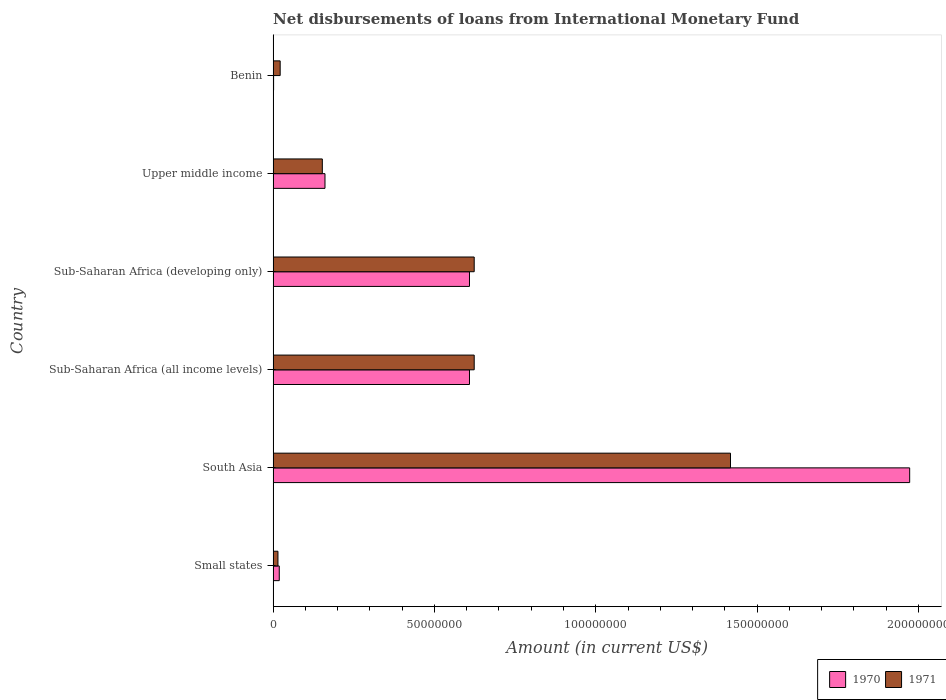How many different coloured bars are there?
Offer a terse response. 2. Are the number of bars per tick equal to the number of legend labels?
Your answer should be compact. Yes. Are the number of bars on each tick of the Y-axis equal?
Ensure brevity in your answer.  Yes. In how many cases, is the number of bars for a given country not equal to the number of legend labels?
Give a very brief answer. 0. What is the amount of loans disbursed in 1971 in Small states?
Offer a very short reply. 1.50e+06. Across all countries, what is the maximum amount of loans disbursed in 1970?
Provide a short and direct response. 1.97e+08. Across all countries, what is the minimum amount of loans disbursed in 1970?
Provide a succinct answer. 1.45e+05. In which country was the amount of loans disbursed in 1970 minimum?
Keep it short and to the point. Benin. What is the total amount of loans disbursed in 1970 in the graph?
Keep it short and to the point. 3.37e+08. What is the difference between the amount of loans disbursed in 1970 in Small states and that in Upper middle income?
Make the answer very short. -1.42e+07. What is the difference between the amount of loans disbursed in 1970 in Benin and the amount of loans disbursed in 1971 in Upper middle income?
Provide a succinct answer. -1.51e+07. What is the average amount of loans disbursed in 1971 per country?
Provide a succinct answer. 4.76e+07. What is the difference between the amount of loans disbursed in 1970 and amount of loans disbursed in 1971 in Small states?
Offer a very short reply. 4.08e+05. In how many countries, is the amount of loans disbursed in 1971 greater than 140000000 US$?
Give a very brief answer. 1. What is the ratio of the amount of loans disbursed in 1971 in Small states to that in Upper middle income?
Your response must be concise. 0.1. Is the amount of loans disbursed in 1971 in Small states less than that in South Asia?
Give a very brief answer. Yes. Is the difference between the amount of loans disbursed in 1970 in South Asia and Upper middle income greater than the difference between the amount of loans disbursed in 1971 in South Asia and Upper middle income?
Make the answer very short. Yes. What is the difference between the highest and the second highest amount of loans disbursed in 1970?
Offer a very short reply. 1.36e+08. What is the difference between the highest and the lowest amount of loans disbursed in 1970?
Your response must be concise. 1.97e+08. What does the 1st bar from the top in South Asia represents?
Provide a succinct answer. 1971. What does the 1st bar from the bottom in Small states represents?
Give a very brief answer. 1970. Are all the bars in the graph horizontal?
Your answer should be compact. Yes. How many countries are there in the graph?
Offer a terse response. 6. What is the difference between two consecutive major ticks on the X-axis?
Provide a short and direct response. 5.00e+07. Does the graph contain grids?
Offer a very short reply. No. How many legend labels are there?
Provide a short and direct response. 2. What is the title of the graph?
Keep it short and to the point. Net disbursements of loans from International Monetary Fund. Does "1982" appear as one of the legend labels in the graph?
Your answer should be very brief. No. What is the label or title of the X-axis?
Provide a short and direct response. Amount (in current US$). What is the Amount (in current US$) in 1970 in Small states?
Offer a very short reply. 1.91e+06. What is the Amount (in current US$) of 1971 in Small states?
Offer a very short reply. 1.50e+06. What is the Amount (in current US$) of 1970 in South Asia?
Keep it short and to the point. 1.97e+08. What is the Amount (in current US$) in 1971 in South Asia?
Give a very brief answer. 1.42e+08. What is the Amount (in current US$) of 1970 in Sub-Saharan Africa (all income levels)?
Provide a short and direct response. 6.09e+07. What is the Amount (in current US$) in 1971 in Sub-Saharan Africa (all income levels)?
Your answer should be very brief. 6.23e+07. What is the Amount (in current US$) of 1970 in Sub-Saharan Africa (developing only)?
Provide a short and direct response. 6.09e+07. What is the Amount (in current US$) in 1971 in Sub-Saharan Africa (developing only)?
Your answer should be compact. 6.23e+07. What is the Amount (in current US$) of 1970 in Upper middle income?
Give a very brief answer. 1.61e+07. What is the Amount (in current US$) of 1971 in Upper middle income?
Give a very brief answer. 1.52e+07. What is the Amount (in current US$) of 1970 in Benin?
Make the answer very short. 1.45e+05. What is the Amount (in current US$) in 1971 in Benin?
Offer a very short reply. 2.19e+06. Across all countries, what is the maximum Amount (in current US$) in 1970?
Your answer should be compact. 1.97e+08. Across all countries, what is the maximum Amount (in current US$) in 1971?
Offer a terse response. 1.42e+08. Across all countries, what is the minimum Amount (in current US$) in 1970?
Your answer should be very brief. 1.45e+05. Across all countries, what is the minimum Amount (in current US$) of 1971?
Provide a succinct answer. 1.50e+06. What is the total Amount (in current US$) of 1970 in the graph?
Keep it short and to the point. 3.37e+08. What is the total Amount (in current US$) of 1971 in the graph?
Make the answer very short. 2.85e+08. What is the difference between the Amount (in current US$) in 1970 in Small states and that in South Asia?
Ensure brevity in your answer.  -1.95e+08. What is the difference between the Amount (in current US$) in 1971 in Small states and that in South Asia?
Provide a short and direct response. -1.40e+08. What is the difference between the Amount (in current US$) of 1970 in Small states and that in Sub-Saharan Africa (all income levels)?
Ensure brevity in your answer.  -5.90e+07. What is the difference between the Amount (in current US$) in 1971 in Small states and that in Sub-Saharan Africa (all income levels)?
Make the answer very short. -6.08e+07. What is the difference between the Amount (in current US$) of 1970 in Small states and that in Sub-Saharan Africa (developing only)?
Your answer should be very brief. -5.90e+07. What is the difference between the Amount (in current US$) in 1971 in Small states and that in Sub-Saharan Africa (developing only)?
Provide a short and direct response. -6.08e+07. What is the difference between the Amount (in current US$) in 1970 in Small states and that in Upper middle income?
Ensure brevity in your answer.  -1.42e+07. What is the difference between the Amount (in current US$) of 1971 in Small states and that in Upper middle income?
Your response must be concise. -1.38e+07. What is the difference between the Amount (in current US$) in 1970 in Small states and that in Benin?
Ensure brevity in your answer.  1.76e+06. What is the difference between the Amount (in current US$) in 1971 in Small states and that in Benin?
Offer a very short reply. -6.88e+05. What is the difference between the Amount (in current US$) of 1970 in South Asia and that in Sub-Saharan Africa (all income levels)?
Your answer should be very brief. 1.36e+08. What is the difference between the Amount (in current US$) in 1971 in South Asia and that in Sub-Saharan Africa (all income levels)?
Make the answer very short. 7.94e+07. What is the difference between the Amount (in current US$) in 1970 in South Asia and that in Sub-Saharan Africa (developing only)?
Your response must be concise. 1.36e+08. What is the difference between the Amount (in current US$) in 1971 in South Asia and that in Sub-Saharan Africa (developing only)?
Keep it short and to the point. 7.94e+07. What is the difference between the Amount (in current US$) in 1970 in South Asia and that in Upper middle income?
Provide a short and direct response. 1.81e+08. What is the difference between the Amount (in current US$) of 1971 in South Asia and that in Upper middle income?
Give a very brief answer. 1.26e+08. What is the difference between the Amount (in current US$) of 1970 in South Asia and that in Benin?
Ensure brevity in your answer.  1.97e+08. What is the difference between the Amount (in current US$) in 1971 in South Asia and that in Benin?
Your answer should be very brief. 1.40e+08. What is the difference between the Amount (in current US$) in 1970 in Sub-Saharan Africa (all income levels) and that in Sub-Saharan Africa (developing only)?
Offer a terse response. 0. What is the difference between the Amount (in current US$) of 1971 in Sub-Saharan Africa (all income levels) and that in Sub-Saharan Africa (developing only)?
Offer a terse response. 0. What is the difference between the Amount (in current US$) of 1970 in Sub-Saharan Africa (all income levels) and that in Upper middle income?
Provide a short and direct response. 4.48e+07. What is the difference between the Amount (in current US$) in 1971 in Sub-Saharan Africa (all income levels) and that in Upper middle income?
Give a very brief answer. 4.71e+07. What is the difference between the Amount (in current US$) in 1970 in Sub-Saharan Africa (all income levels) and that in Benin?
Keep it short and to the point. 6.07e+07. What is the difference between the Amount (in current US$) in 1971 in Sub-Saharan Africa (all income levels) and that in Benin?
Provide a short and direct response. 6.01e+07. What is the difference between the Amount (in current US$) of 1970 in Sub-Saharan Africa (developing only) and that in Upper middle income?
Keep it short and to the point. 4.48e+07. What is the difference between the Amount (in current US$) of 1971 in Sub-Saharan Africa (developing only) and that in Upper middle income?
Provide a short and direct response. 4.71e+07. What is the difference between the Amount (in current US$) in 1970 in Sub-Saharan Africa (developing only) and that in Benin?
Give a very brief answer. 6.07e+07. What is the difference between the Amount (in current US$) in 1971 in Sub-Saharan Africa (developing only) and that in Benin?
Keep it short and to the point. 6.01e+07. What is the difference between the Amount (in current US$) of 1970 in Upper middle income and that in Benin?
Provide a short and direct response. 1.59e+07. What is the difference between the Amount (in current US$) of 1971 in Upper middle income and that in Benin?
Your response must be concise. 1.31e+07. What is the difference between the Amount (in current US$) of 1970 in Small states and the Amount (in current US$) of 1971 in South Asia?
Offer a very short reply. -1.40e+08. What is the difference between the Amount (in current US$) of 1970 in Small states and the Amount (in current US$) of 1971 in Sub-Saharan Africa (all income levels)?
Offer a very short reply. -6.04e+07. What is the difference between the Amount (in current US$) in 1970 in Small states and the Amount (in current US$) in 1971 in Sub-Saharan Africa (developing only)?
Ensure brevity in your answer.  -6.04e+07. What is the difference between the Amount (in current US$) in 1970 in Small states and the Amount (in current US$) in 1971 in Upper middle income?
Provide a succinct answer. -1.33e+07. What is the difference between the Amount (in current US$) of 1970 in Small states and the Amount (in current US$) of 1971 in Benin?
Make the answer very short. -2.80e+05. What is the difference between the Amount (in current US$) in 1970 in South Asia and the Amount (in current US$) in 1971 in Sub-Saharan Africa (all income levels)?
Ensure brevity in your answer.  1.35e+08. What is the difference between the Amount (in current US$) of 1970 in South Asia and the Amount (in current US$) of 1971 in Sub-Saharan Africa (developing only)?
Offer a terse response. 1.35e+08. What is the difference between the Amount (in current US$) in 1970 in South Asia and the Amount (in current US$) in 1971 in Upper middle income?
Ensure brevity in your answer.  1.82e+08. What is the difference between the Amount (in current US$) in 1970 in South Asia and the Amount (in current US$) in 1971 in Benin?
Keep it short and to the point. 1.95e+08. What is the difference between the Amount (in current US$) of 1970 in Sub-Saharan Africa (all income levels) and the Amount (in current US$) of 1971 in Sub-Saharan Africa (developing only)?
Provide a short and direct response. -1.46e+06. What is the difference between the Amount (in current US$) of 1970 in Sub-Saharan Africa (all income levels) and the Amount (in current US$) of 1971 in Upper middle income?
Your answer should be compact. 4.56e+07. What is the difference between the Amount (in current US$) of 1970 in Sub-Saharan Africa (all income levels) and the Amount (in current US$) of 1971 in Benin?
Make the answer very short. 5.87e+07. What is the difference between the Amount (in current US$) in 1970 in Sub-Saharan Africa (developing only) and the Amount (in current US$) in 1971 in Upper middle income?
Your answer should be compact. 4.56e+07. What is the difference between the Amount (in current US$) in 1970 in Sub-Saharan Africa (developing only) and the Amount (in current US$) in 1971 in Benin?
Your response must be concise. 5.87e+07. What is the difference between the Amount (in current US$) in 1970 in Upper middle income and the Amount (in current US$) in 1971 in Benin?
Offer a very short reply. 1.39e+07. What is the average Amount (in current US$) in 1970 per country?
Give a very brief answer. 5.62e+07. What is the average Amount (in current US$) of 1971 per country?
Provide a succinct answer. 4.76e+07. What is the difference between the Amount (in current US$) of 1970 and Amount (in current US$) of 1971 in Small states?
Provide a short and direct response. 4.08e+05. What is the difference between the Amount (in current US$) in 1970 and Amount (in current US$) in 1971 in South Asia?
Offer a terse response. 5.55e+07. What is the difference between the Amount (in current US$) in 1970 and Amount (in current US$) in 1971 in Sub-Saharan Africa (all income levels)?
Give a very brief answer. -1.46e+06. What is the difference between the Amount (in current US$) in 1970 and Amount (in current US$) in 1971 in Sub-Saharan Africa (developing only)?
Your response must be concise. -1.46e+06. What is the difference between the Amount (in current US$) of 1970 and Amount (in current US$) of 1971 in Upper middle income?
Make the answer very short. 8.24e+05. What is the difference between the Amount (in current US$) in 1970 and Amount (in current US$) in 1971 in Benin?
Offer a very short reply. -2.04e+06. What is the ratio of the Amount (in current US$) in 1970 in Small states to that in South Asia?
Your answer should be very brief. 0.01. What is the ratio of the Amount (in current US$) of 1971 in Small states to that in South Asia?
Your answer should be compact. 0.01. What is the ratio of the Amount (in current US$) of 1970 in Small states to that in Sub-Saharan Africa (all income levels)?
Make the answer very short. 0.03. What is the ratio of the Amount (in current US$) in 1971 in Small states to that in Sub-Saharan Africa (all income levels)?
Your answer should be compact. 0.02. What is the ratio of the Amount (in current US$) in 1970 in Small states to that in Sub-Saharan Africa (developing only)?
Make the answer very short. 0.03. What is the ratio of the Amount (in current US$) of 1971 in Small states to that in Sub-Saharan Africa (developing only)?
Give a very brief answer. 0.02. What is the ratio of the Amount (in current US$) of 1970 in Small states to that in Upper middle income?
Keep it short and to the point. 0.12. What is the ratio of the Amount (in current US$) of 1971 in Small states to that in Upper middle income?
Your response must be concise. 0.1. What is the ratio of the Amount (in current US$) of 1970 in Small states to that in Benin?
Make the answer very short. 13.14. What is the ratio of the Amount (in current US$) in 1971 in Small states to that in Benin?
Your answer should be compact. 0.69. What is the ratio of the Amount (in current US$) in 1970 in South Asia to that in Sub-Saharan Africa (all income levels)?
Keep it short and to the point. 3.24. What is the ratio of the Amount (in current US$) in 1971 in South Asia to that in Sub-Saharan Africa (all income levels)?
Provide a succinct answer. 2.27. What is the ratio of the Amount (in current US$) in 1970 in South Asia to that in Sub-Saharan Africa (developing only)?
Offer a terse response. 3.24. What is the ratio of the Amount (in current US$) in 1971 in South Asia to that in Sub-Saharan Africa (developing only)?
Provide a short and direct response. 2.27. What is the ratio of the Amount (in current US$) of 1970 in South Asia to that in Upper middle income?
Make the answer very short. 12.27. What is the ratio of the Amount (in current US$) in 1971 in South Asia to that in Upper middle income?
Provide a short and direct response. 9.29. What is the ratio of the Amount (in current US$) in 1970 in South Asia to that in Benin?
Your answer should be compact. 1360.52. What is the ratio of the Amount (in current US$) in 1971 in South Asia to that in Benin?
Offer a terse response. 64.84. What is the ratio of the Amount (in current US$) in 1970 in Sub-Saharan Africa (all income levels) to that in Sub-Saharan Africa (developing only)?
Provide a short and direct response. 1. What is the ratio of the Amount (in current US$) in 1970 in Sub-Saharan Africa (all income levels) to that in Upper middle income?
Ensure brevity in your answer.  3.79. What is the ratio of the Amount (in current US$) in 1971 in Sub-Saharan Africa (all income levels) to that in Upper middle income?
Your answer should be very brief. 4.09. What is the ratio of the Amount (in current US$) in 1970 in Sub-Saharan Africa (all income levels) to that in Benin?
Make the answer very short. 419.7. What is the ratio of the Amount (in current US$) in 1971 in Sub-Saharan Africa (all income levels) to that in Benin?
Your answer should be compact. 28.51. What is the ratio of the Amount (in current US$) in 1970 in Sub-Saharan Africa (developing only) to that in Upper middle income?
Ensure brevity in your answer.  3.79. What is the ratio of the Amount (in current US$) in 1971 in Sub-Saharan Africa (developing only) to that in Upper middle income?
Give a very brief answer. 4.09. What is the ratio of the Amount (in current US$) of 1970 in Sub-Saharan Africa (developing only) to that in Benin?
Your answer should be very brief. 419.7. What is the ratio of the Amount (in current US$) of 1971 in Sub-Saharan Africa (developing only) to that in Benin?
Your answer should be very brief. 28.51. What is the ratio of the Amount (in current US$) in 1970 in Upper middle income to that in Benin?
Your answer should be compact. 110.86. What is the ratio of the Amount (in current US$) in 1971 in Upper middle income to that in Benin?
Provide a succinct answer. 6.98. What is the difference between the highest and the second highest Amount (in current US$) of 1970?
Your answer should be compact. 1.36e+08. What is the difference between the highest and the second highest Amount (in current US$) of 1971?
Give a very brief answer. 7.94e+07. What is the difference between the highest and the lowest Amount (in current US$) in 1970?
Provide a succinct answer. 1.97e+08. What is the difference between the highest and the lowest Amount (in current US$) in 1971?
Offer a terse response. 1.40e+08. 